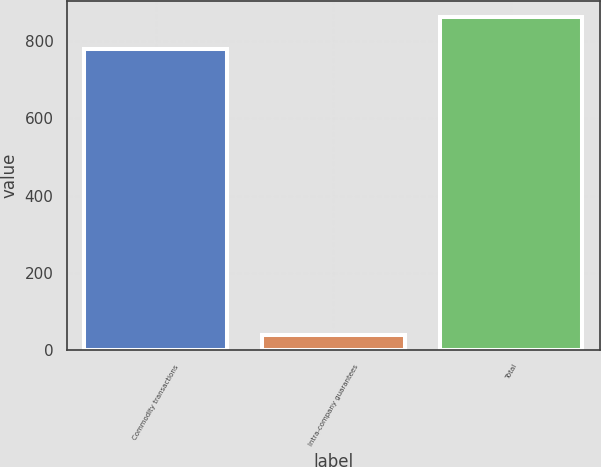<chart> <loc_0><loc_0><loc_500><loc_500><bar_chart><fcel>Commodity transactions<fcel>Intra-company guarantees<fcel>Total<nl><fcel>780<fcel>40<fcel>861.2<nl></chart> 